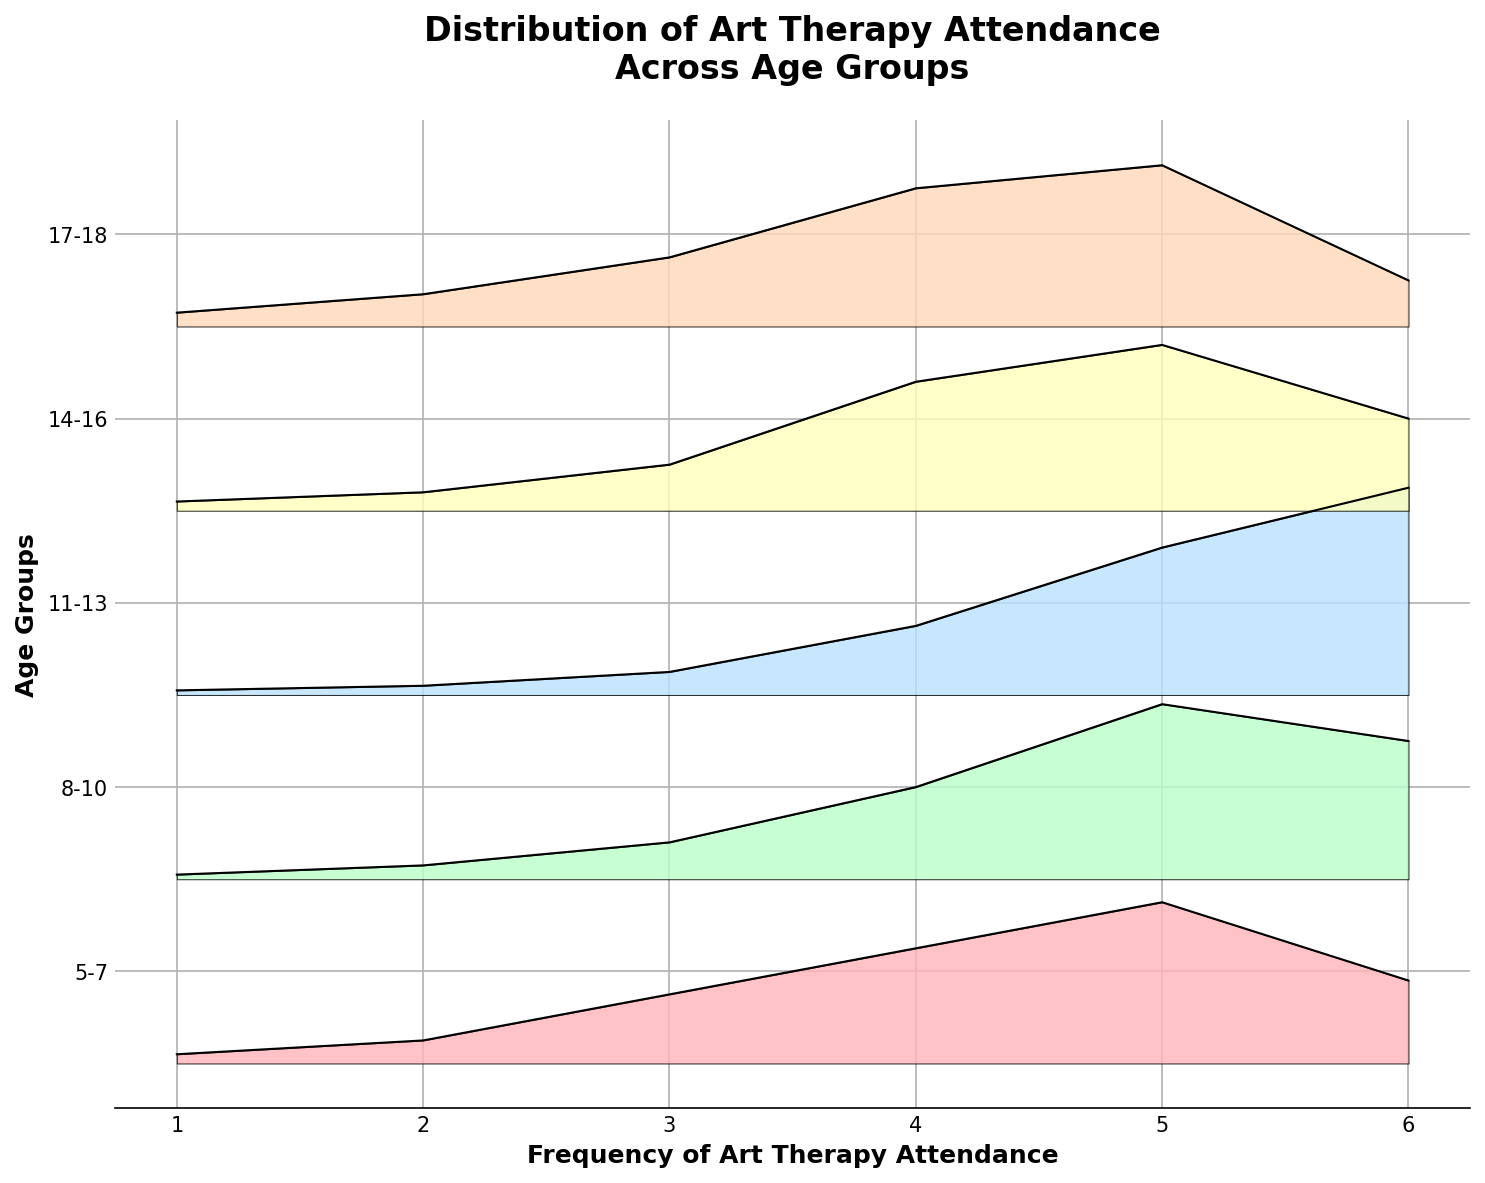What is the range of frequencies for art therapy attendance shown on the x-axis? The x-axis shows frequencies from 1 to 6 for art therapy attendance, as indicated by the tick marks and labels.
Answer: 1 to 6 Which age group has the highest density at 6 attendances? The age group 11-13 has the highest density at 6 attendances, as its line reaches the highest point on the plot for this frequency.
Answer: 11-13 For the age group 5-7, which frequency has the maximum density? By observing the plot, the 5th frequency for the age group 5-7 has the maximum density because that point is the highest on the line for this group.
Answer: 5 How do the densities at 4 attendances compare between the age groups 14-16 and 17-18? The density for the 17-18 age group is higher at 4 attendances compared to the 14-16 age group, as the top of the density curve for 17-18 is above that of 14-16.
Answer: 17-18 > 14-16 What general trend is observed with increasing frequency of attendance for the age group 8-10? The density for the 8-10 age group generally increases with higher frequencies, peaking at 5 attendances and slightly decreasing at 6.
Answer: Increasing What is the overall shape of the density curve for the age group 17-18? The density curve for the age group 17-18 increases, peaking at 4 attendances, then decreases.
Answer: Increase then decrease Which age group displays the broadest range of densities across the different frequencies? The age group 17-18 displays a broad range of densities as it has considerable variability at different frequencies.
Answer: 17-18 Are there any age groups where attendances are distributed more evenly across frequencies? The age group 14-16 has a relatively even distribution across the frequencies, without extreme peaks or troughs.
Answer: 14-16 Which age group has the most skewed distribution towards higher frequencies? The age group 11-13 is most skewed towards higher frequencies, as shown by the higher densities at the higher attendance numbers.
Answer: 11-13 